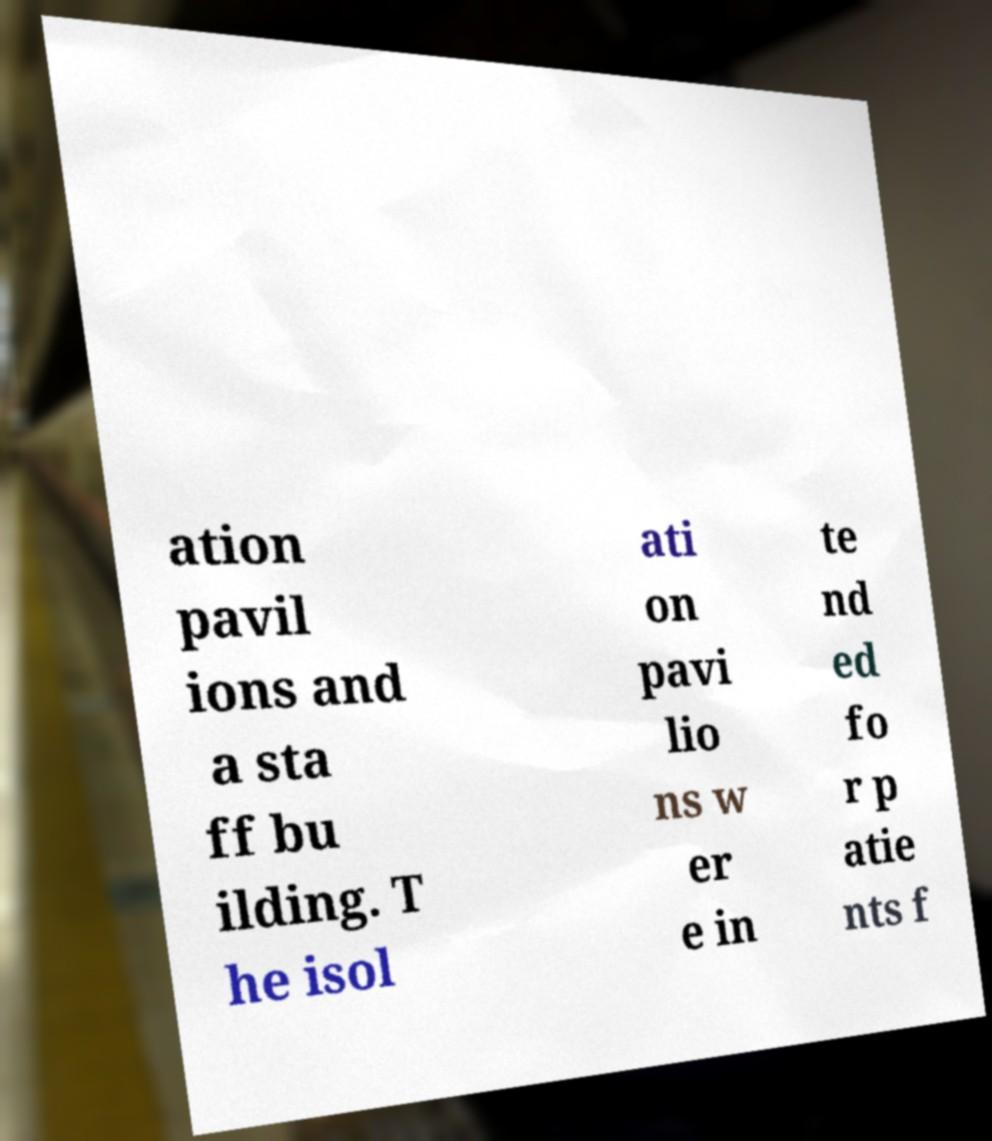Could you extract and type out the text from this image? ation pavil ions and a sta ff bu ilding. T he isol ati on pavi lio ns w er e in te nd ed fo r p atie nts f 